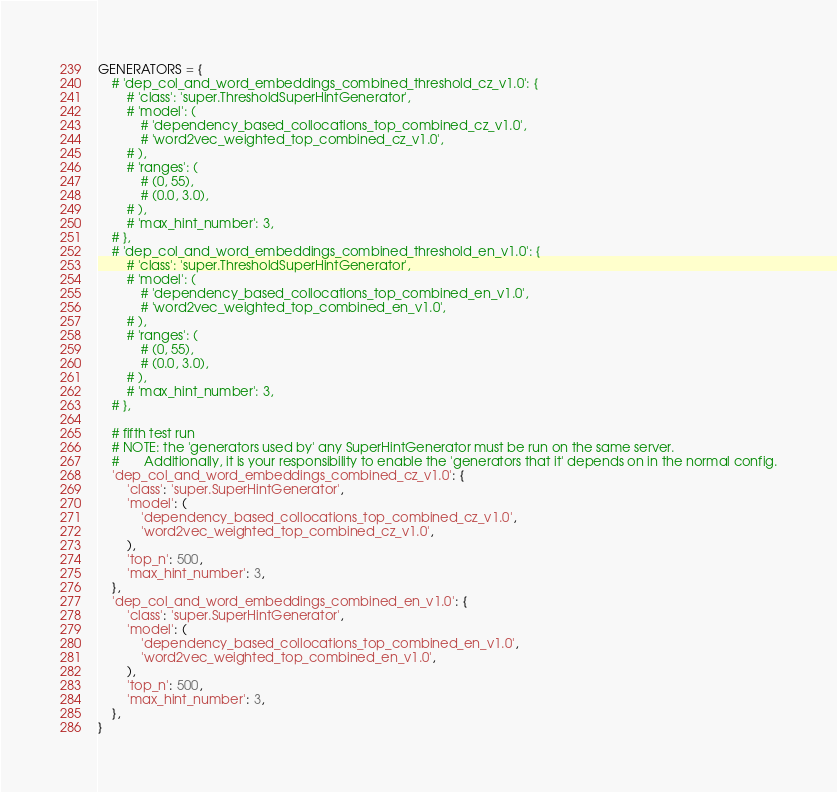<code> <loc_0><loc_0><loc_500><loc_500><_Python_>
GENERATORS = {
	# 'dep_col_and_word_embeddings_combined_threshold_cz_v1.0': {
		# 'class': 'super.ThresholdSuperHintGenerator',
		# 'model': (
			# 'dependency_based_collocations_top_combined_cz_v1.0',
			# 'word2vec_weighted_top_combined_cz_v1.0',
		# ),
		# 'ranges': (
			# (0, 55),
			# (0.0, 3.0),
		# ),
		# 'max_hint_number': 3,
	# },
	# 'dep_col_and_word_embeddings_combined_threshold_en_v1.0': {
		# 'class': 'super.ThresholdSuperHintGenerator',
		# 'model': (
			# 'dependency_based_collocations_top_combined_en_v1.0',
			# 'word2vec_weighted_top_combined_en_v1.0',
		# ),
		# 'ranges': (
			# (0, 55),
			# (0.0, 3.0),
		# ),
		# 'max_hint_number': 3,
	# },
	
	# fifth test run
	# NOTE: the 'generators used by' any SuperHintGenerator must be run on the same server.
	#		Additionally, it is your responsibility to enable the 'generators that it' depends on in the normal config.
	'dep_col_and_word_embeddings_combined_cz_v1.0': {
		'class': 'super.SuperHintGenerator',
		'model': (
			'dependency_based_collocations_top_combined_cz_v1.0',
			'word2vec_weighted_top_combined_cz_v1.0',
		),
		'top_n': 500,
		'max_hint_number': 3,
	},
	'dep_col_and_word_embeddings_combined_en_v1.0': {
		'class': 'super.SuperHintGenerator',
		'model': (
			'dependency_based_collocations_top_combined_en_v1.0',
			'word2vec_weighted_top_combined_en_v1.0',
		),
		'top_n': 500,
		'max_hint_number': 3,
	},
}
</code> 